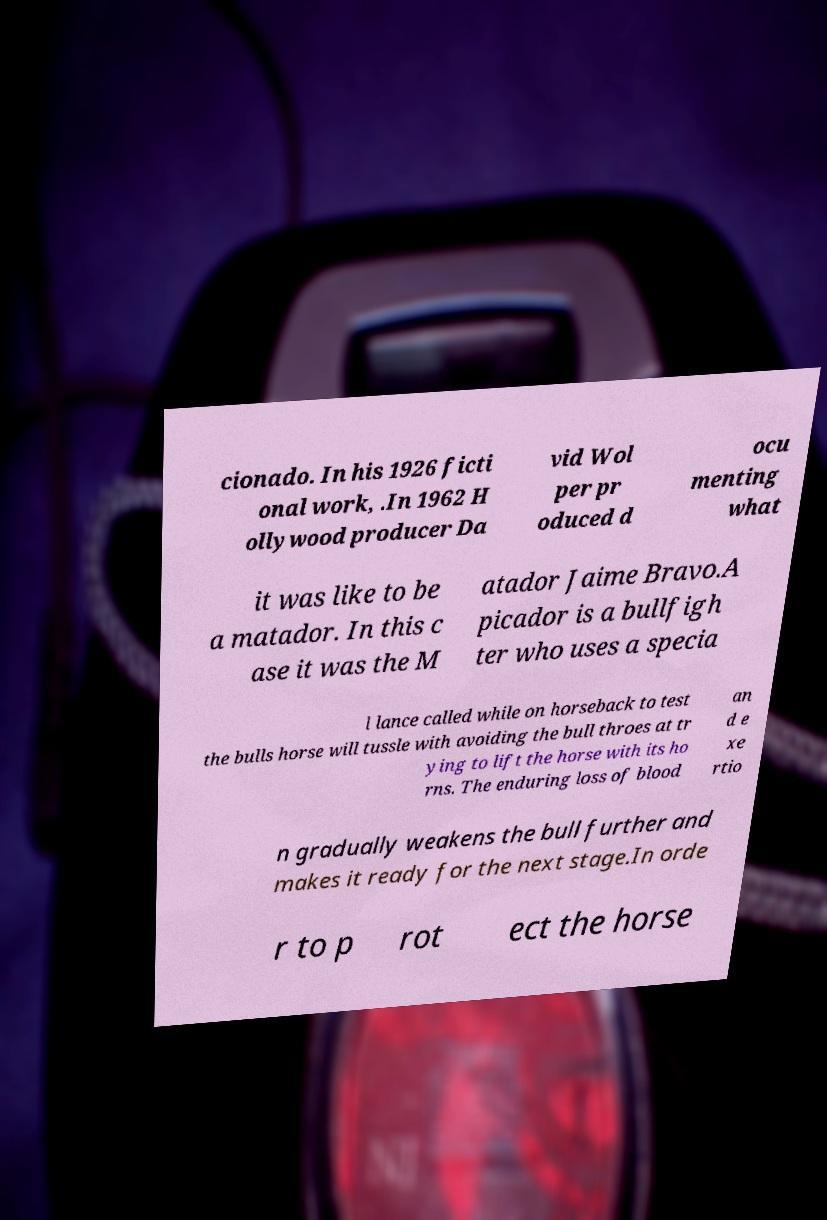For documentation purposes, I need the text within this image transcribed. Could you provide that? cionado. In his 1926 ficti onal work, .In 1962 H ollywood producer Da vid Wol per pr oduced d ocu menting what it was like to be a matador. In this c ase it was the M atador Jaime Bravo.A picador is a bullfigh ter who uses a specia l lance called while on horseback to test the bulls horse will tussle with avoiding the bull throes at tr ying to lift the horse with its ho rns. The enduring loss of blood an d e xe rtio n gradually weakens the bull further and makes it ready for the next stage.In orde r to p rot ect the horse 